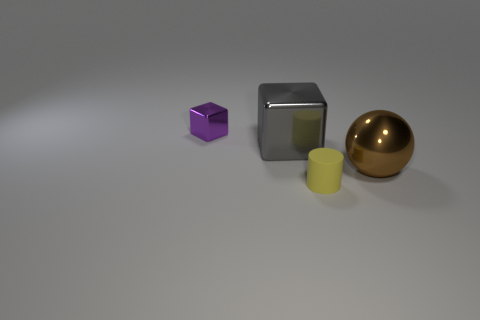Are there any tiny matte cylinders of the same color as the large metal sphere?
Your answer should be very brief. No. Are there an equal number of large brown metal balls that are in front of the yellow matte cylinder and shiny things?
Your answer should be very brief. No. How many brown things are there?
Offer a terse response. 1. There is a thing that is right of the big gray object and behind the tiny matte object; what is its shape?
Ensure brevity in your answer.  Sphere. Do the large object that is to the left of the small yellow matte cylinder and the small object in front of the purple object have the same color?
Provide a succinct answer. No. Are there any large gray things made of the same material as the purple block?
Ensure brevity in your answer.  Yes. Is the number of cubes that are left of the small metal thing the same as the number of large cubes in front of the yellow matte object?
Ensure brevity in your answer.  Yes. There is a thing that is behind the gray metal cube; how big is it?
Keep it short and to the point. Small. There is a object on the right side of the small thing that is in front of the tiny purple metal cube; what is its material?
Keep it short and to the point. Metal. There is a large metallic thing that is to the right of the small thing that is in front of the tiny metal block; what number of spheres are left of it?
Your answer should be very brief. 0. 